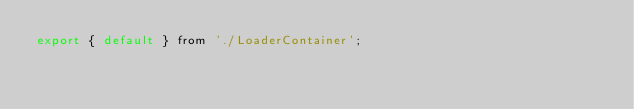Convert code to text. <code><loc_0><loc_0><loc_500><loc_500><_JavaScript_>export { default } from './LoaderContainer';
</code> 